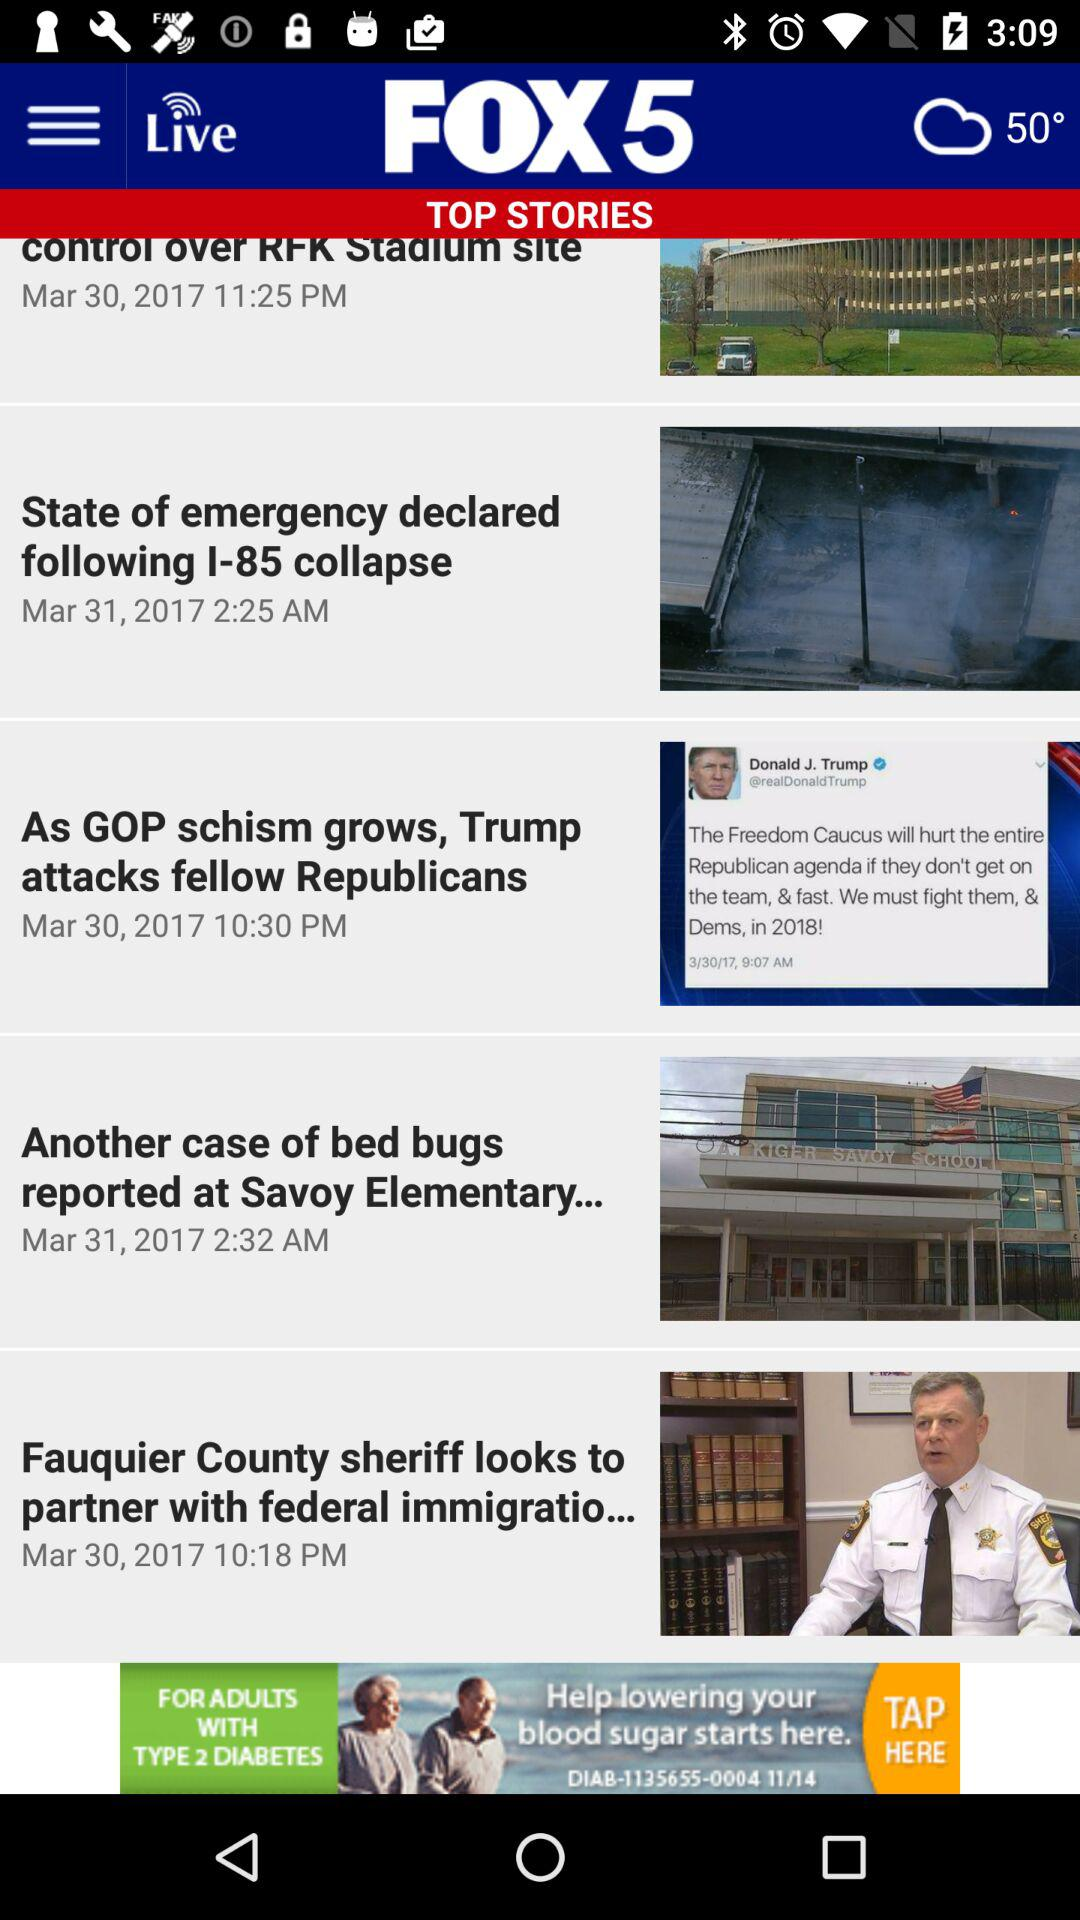How many stories are there in total?
Answer the question using a single word or phrase. 5 